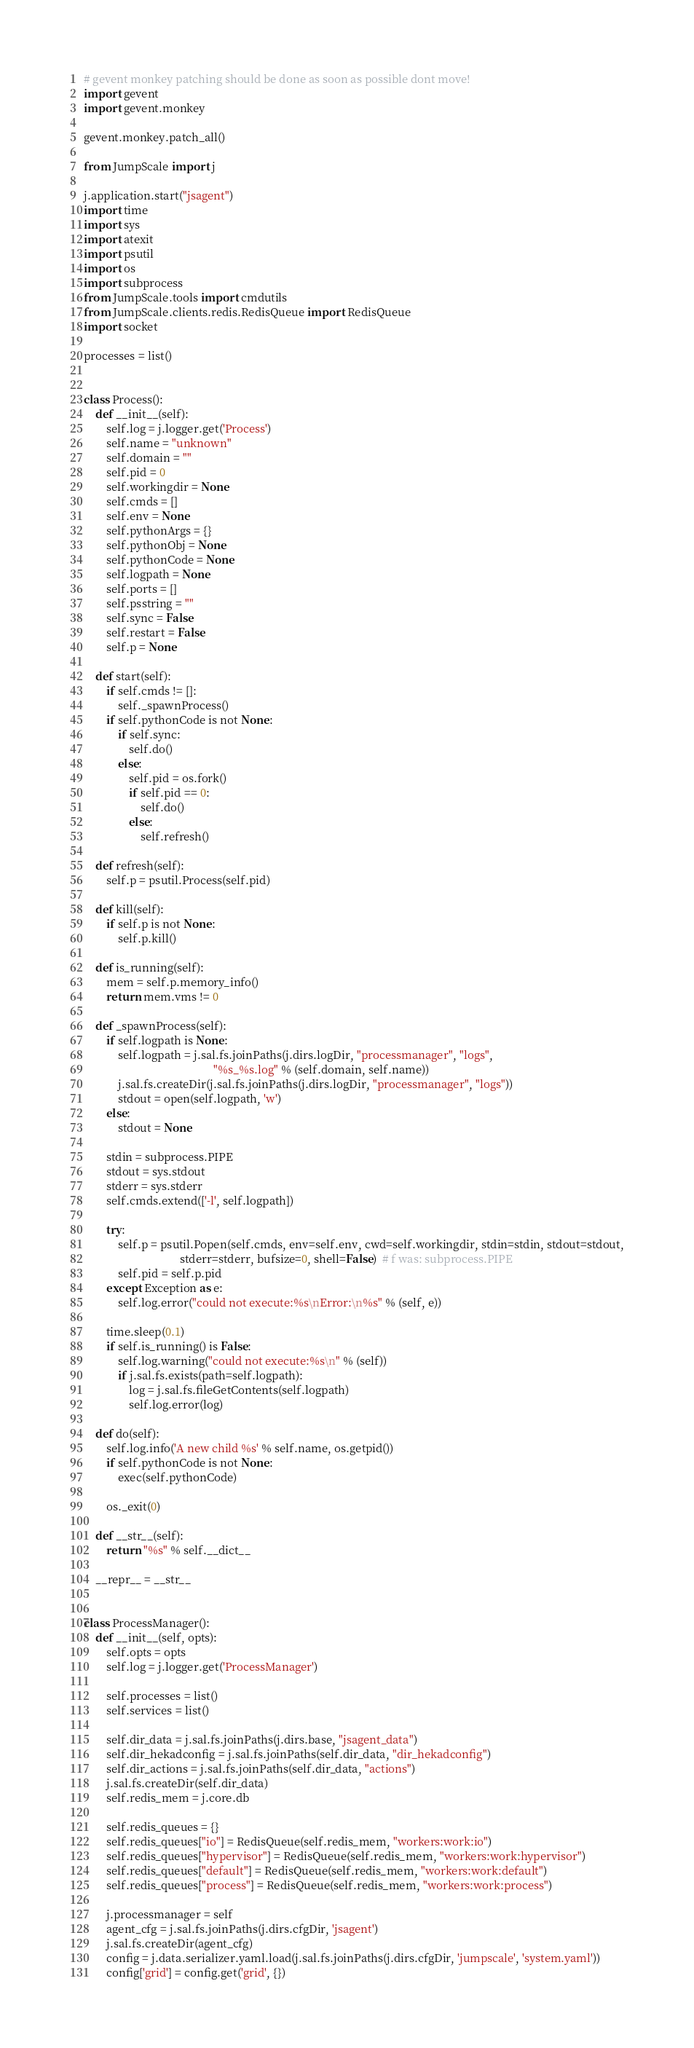Convert code to text. <code><loc_0><loc_0><loc_500><loc_500><_Python_># gevent monkey patching should be done as soon as possible dont move!
import gevent
import gevent.monkey

gevent.monkey.patch_all()

from JumpScale import j

j.application.start("jsagent")
import time
import sys
import atexit
import psutil
import os
import subprocess
from JumpScale.tools import cmdutils
from JumpScale.clients.redis.RedisQueue import RedisQueue
import socket

processes = list()


class Process():
    def __init__(self):
        self.log = j.logger.get('Process')
        self.name = "unknown"
        self.domain = ""
        self.pid = 0
        self.workingdir = None
        self.cmds = []
        self.env = None
        self.pythonArgs = {}
        self.pythonObj = None
        self.pythonCode = None
        self.logpath = None
        self.ports = []
        self.psstring = ""
        self.sync = False
        self.restart = False
        self.p = None

    def start(self):
        if self.cmds != []:
            self._spawnProcess()
        if self.pythonCode is not None:
            if self.sync:
                self.do()
            else:
                self.pid = os.fork()
                if self.pid == 0:
                    self.do()
                else:
                    self.refresh()

    def refresh(self):
        self.p = psutil.Process(self.pid)

    def kill(self):
        if self.p is not None:
            self.p.kill()

    def is_running(self):
        mem = self.p.memory_info()
        return mem.vms != 0

    def _spawnProcess(self):
        if self.logpath is None:
            self.logpath = j.sal.fs.joinPaths(j.dirs.logDir, "processmanager", "logs",
                                              "%s_%s.log" % (self.domain, self.name))
            j.sal.fs.createDir(j.sal.fs.joinPaths(j.dirs.logDir, "processmanager", "logs"))
            stdout = open(self.logpath, 'w')
        else:
            stdout = None

        stdin = subprocess.PIPE
        stdout = sys.stdout
        stderr = sys.stderr
        self.cmds.extend(['-l', self.logpath])

        try:
            self.p = psutil.Popen(self.cmds, env=self.env, cwd=self.workingdir, stdin=stdin, stdout=stdout,
                                  stderr=stderr, bufsize=0, shell=False)  # f was: subprocess.PIPE
            self.pid = self.p.pid
        except Exception as e:
            self.log.error("could not execute:%s\nError:\n%s" % (self, e))

        time.sleep(0.1)
        if self.is_running() is False:
            self.log.warning("could not execute:%s\n" % (self))
            if j.sal.fs.exists(path=self.logpath):
                log = j.sal.fs.fileGetContents(self.logpath)
                self.log.error(log)

    def do(self):
        self.log.info('A new child %s' % self.name, os.getpid())
        if self.pythonCode is not None:
            exec(self.pythonCode)

        os._exit(0)

    def __str__(self):
        return "%s" % self.__dict__

    __repr__ = __str__


class ProcessManager():
    def __init__(self, opts):
        self.opts = opts
        self.log = j.logger.get('ProcessManager')

        self.processes = list()
        self.services = list()

        self.dir_data = j.sal.fs.joinPaths(j.dirs.base, "jsagent_data")
        self.dir_hekadconfig = j.sal.fs.joinPaths(self.dir_data, "dir_hekadconfig")
        self.dir_actions = j.sal.fs.joinPaths(self.dir_data, "actions")
        j.sal.fs.createDir(self.dir_data)
        self.redis_mem = j.core.db

        self.redis_queues = {}
        self.redis_queues["io"] = RedisQueue(self.redis_mem, "workers:work:io")
        self.redis_queues["hypervisor"] = RedisQueue(self.redis_mem, "workers:work:hypervisor")
        self.redis_queues["default"] = RedisQueue(self.redis_mem, "workers:work:default")
        self.redis_queues["process"] = RedisQueue(self.redis_mem, "workers:work:process")

        j.processmanager = self
        agent_cfg = j.sal.fs.joinPaths(j.dirs.cfgDir, 'jsagent')
        j.sal.fs.createDir(agent_cfg)
        config = j.data.serializer.yaml.load(j.sal.fs.joinPaths(j.dirs.cfgDir, 'jumpscale', 'system.yaml'))
        config['grid'] = config.get('grid', {})</code> 